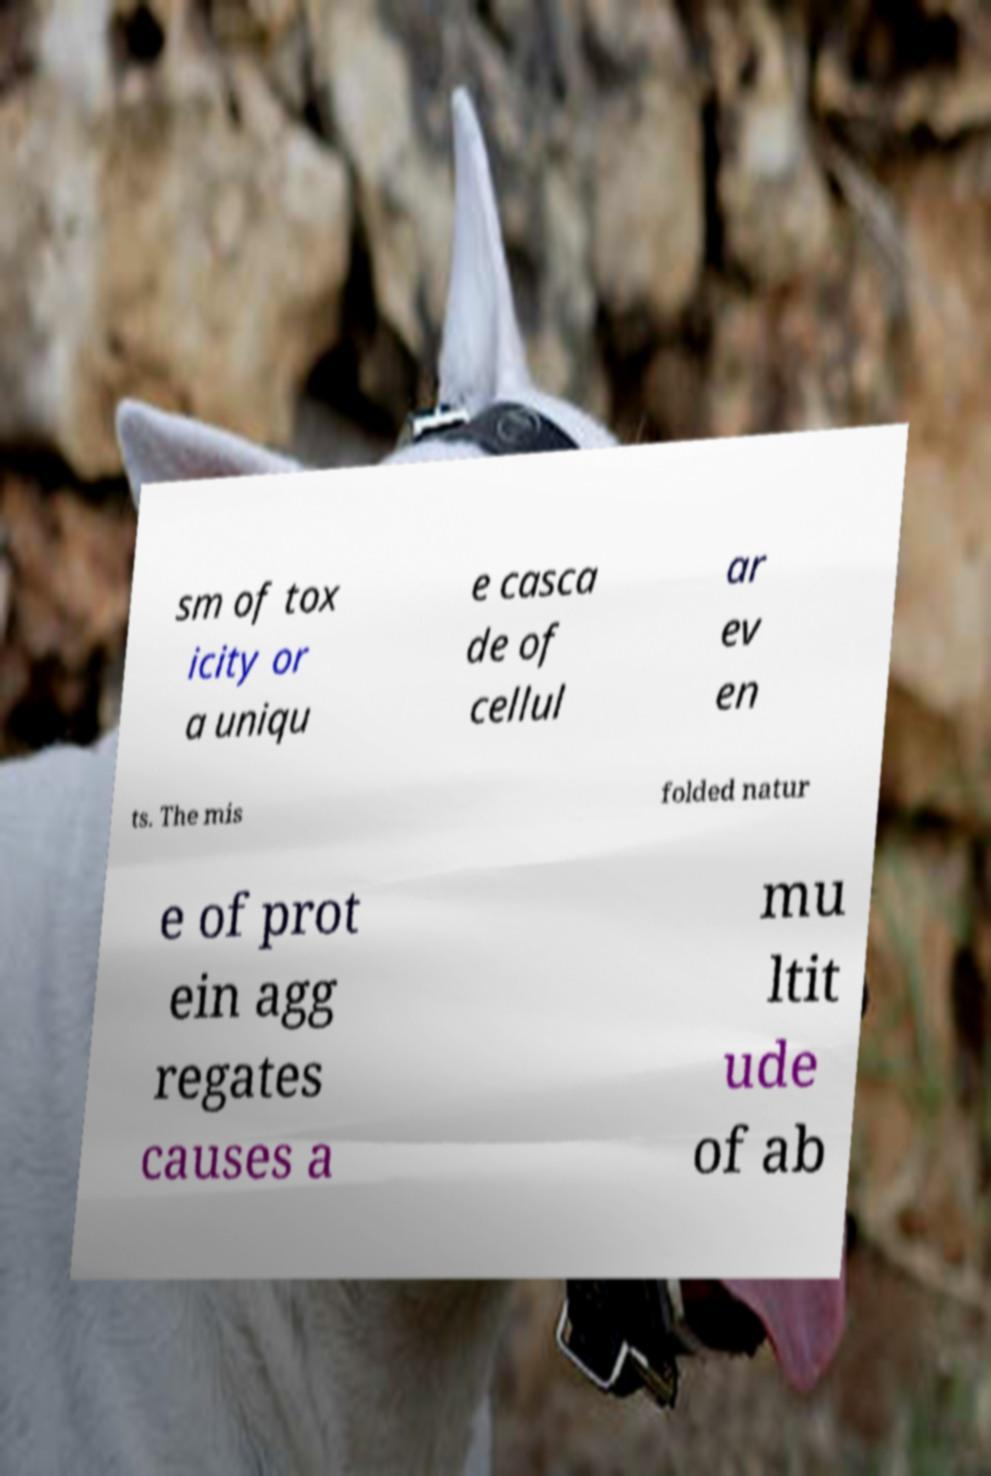Could you extract and type out the text from this image? sm of tox icity or a uniqu e casca de of cellul ar ev en ts. The mis folded natur e of prot ein agg regates causes a mu ltit ude of ab 